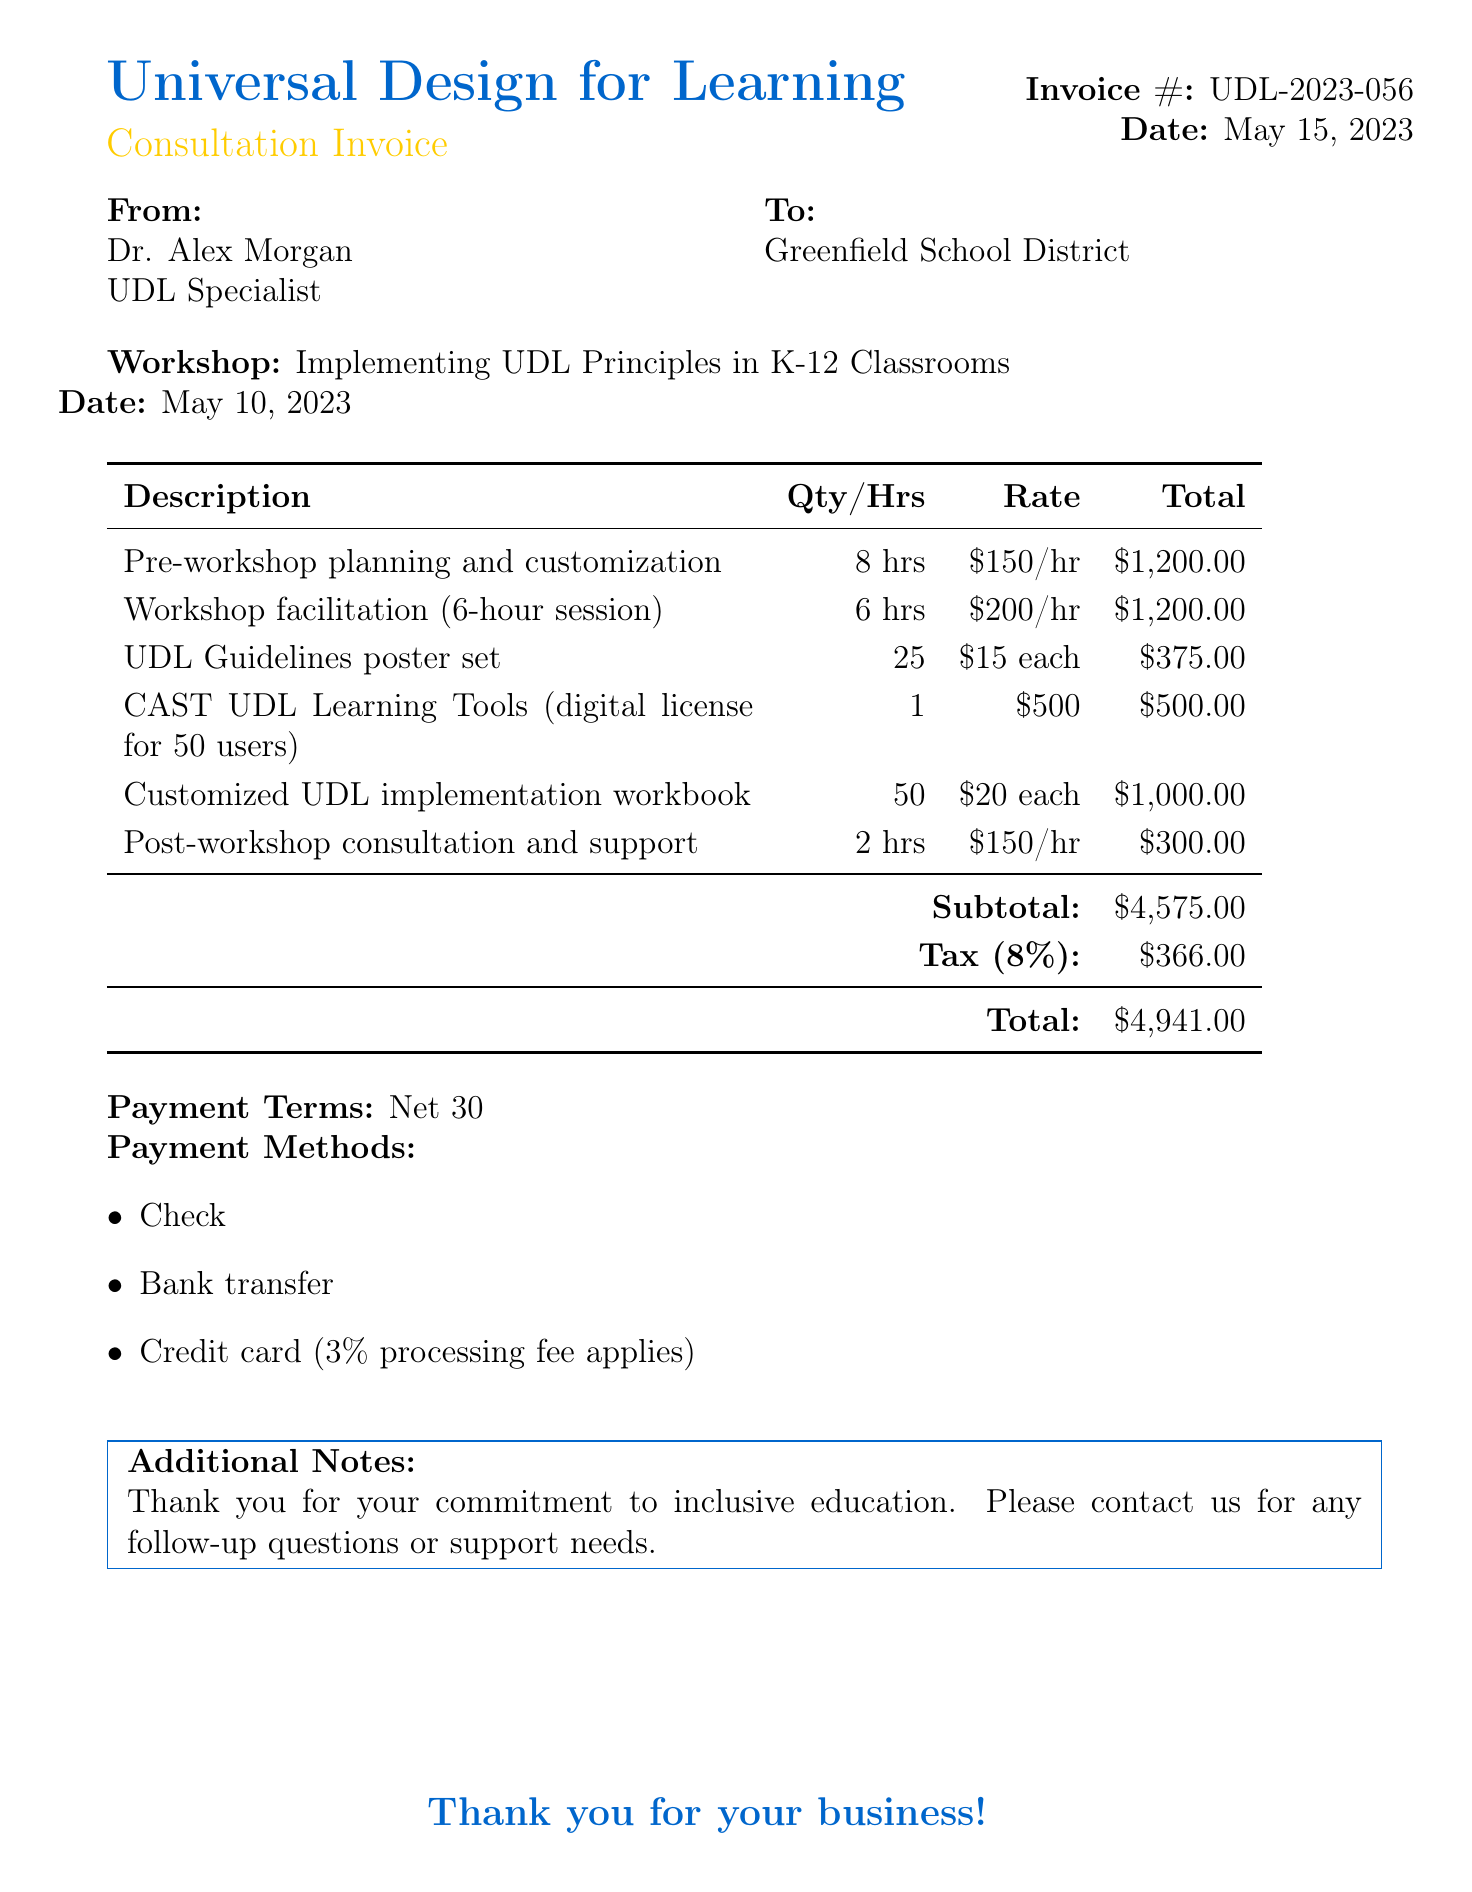What is the invoice number? The invoice number is clearly indicated in the document, which is UDL-2023-056.
Answer: UDL-2023-056 Who is the consultant? The consultant's name is provided in the document, which is Dr. Alex Morgan.
Answer: Dr. Alex Morgan What is the total amount due? The total amount due is stated at the bottom of the document as $4,941.00.
Answer: $4,941.00 How many hours were spent on workshop facilitation? The document specifies that 6 hours were spent on workshop facilitation.
Answer: 6 hours What is the payment terms? The payment terms are outlined in the document, stating "Net 30."
Answer: Net 30 What item was provided in 25 copies? The document lists a UDL Guidelines poster set provided in 25 copies.
Answer: UDL Guidelines poster set What is the tax rate applied? The tax rate is stated clearly in the document, which is 8%.
Answer: 8% How many copies of the customized UDL implementation workbook were included? The document indicates that 50 copies of the workbook were included.
Answer: 50 copies What payment methods are accepted? The document lists several payment methods including Check, Bank transfer, and Credit card.
Answer: Check, Bank transfer, Credit card 